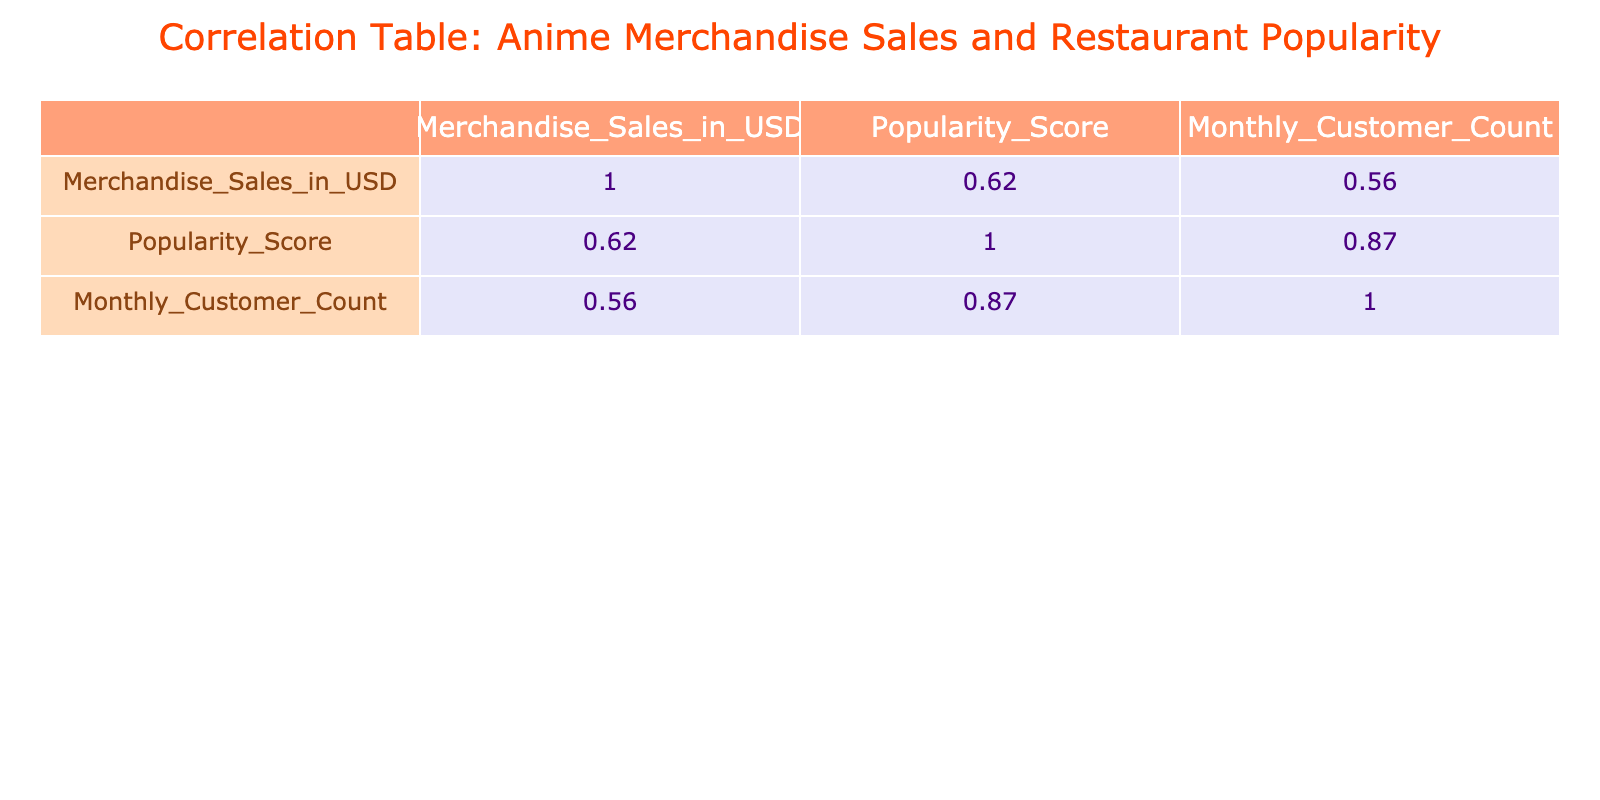What is the highest merchandise sales amount listed in the table? By inspecting the "Merchandise_Sales_in_USD" column, the highest value is 2500000 associated with "Demon Slayer."
Answer: 2500000 What is the average popularity score for all the restaurants listed? To calculate the average, add all the popularity scores (85 + 90 + 75 + 95 + 88 + 92 + 70 + 78 + 67 + 80) which equals 910. Dividing this total by the number of entries (10) gives 910 / 10 = 91.
Answer: 91 Does "Sword Art Online" have a higher popularity score than "Fullmetal Alchemist"? "Sword Art Online" has a popularity score of 78, while "Fullmetal Alchemist" has a score of 80. Thus, Sword Art Online does not have a higher score.
Answer: No Which restaurant has the highest monthly customer count? The "Monthly_Customer_Count" reveals that "Naruto Ramen" has the highest count at 1300 customers.
Answer: Naruto Ramen Is there a correlation between merchandise sales and monthly customer count? Yes, based on the correlation table, there is a positive correlation which indicates that as merchandise sales increase, the monthly customer count tends to increase as well.
Answer: Yes What is the total merchandise sales for all anime titles listed? By summing up the merchandise sales amounts (1500000 + 2000000 + 1800000 + 1200000 + 2500000 + 2200000 + 800000 + 900000 + 850000 + 1300000), the total is 13600000 USD.
Answer: 13600000 Which anime title has the lowest merchandise sales and how much is it? According to the table, "Death Note" has the lowest merchandise sales at 800000 USD.
Answer: Death Note, 800000 How many anime titles have a popularity score greater than 85? By reviewing the scores, the titles with a score greater than 85 are "Naruto," "Attack on Titan," "Demon Slayer," and "Dragon Ball Z," totaling 4 titles.
Answer: 4 Which restaurant corresponds to the anime title with the second highest merchandise sales? The second highest merchandise sales is 2200000 from "Dragon Ball Z," which corresponds to the "Anime Bistro."
Answer: Anime Bistro 